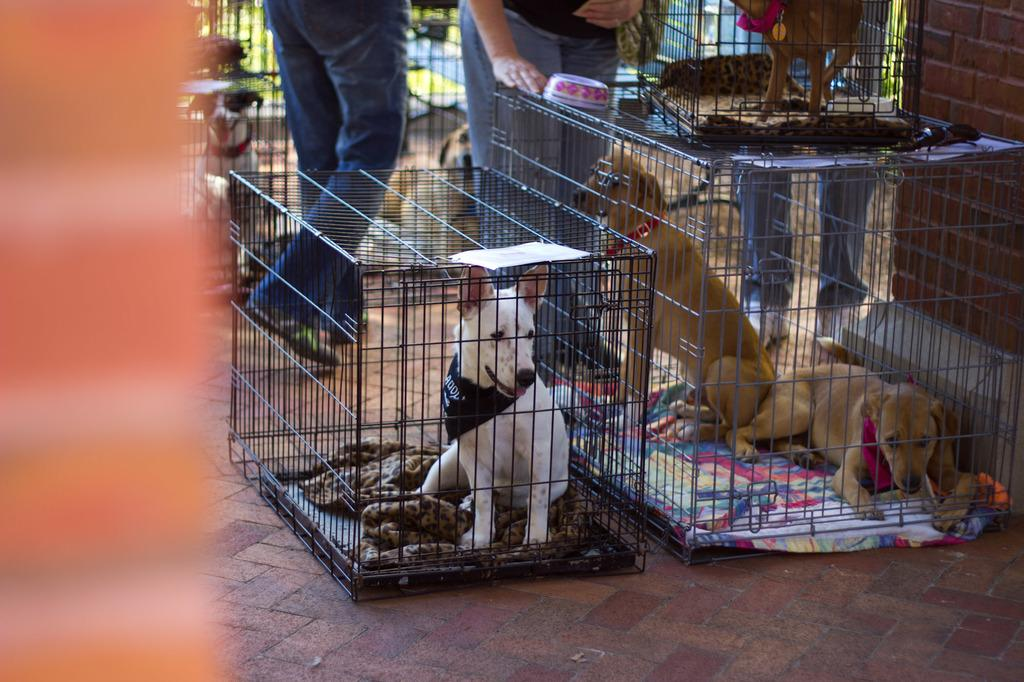What type of animals are in cages in the image? There are dogs in cages in the image. How many people are on the ground in the image? There are three people on the ground in the image. What type of vegetation is visible in the background of the image? There is grass visible in the background of the image. How would you describe the clarity of the background in the image? The background appears blurry. What is the rate of development for the new drug being tested in the image? There is no mention of a drug or any testing in the image; it features dogs in cages and people on the ground. 